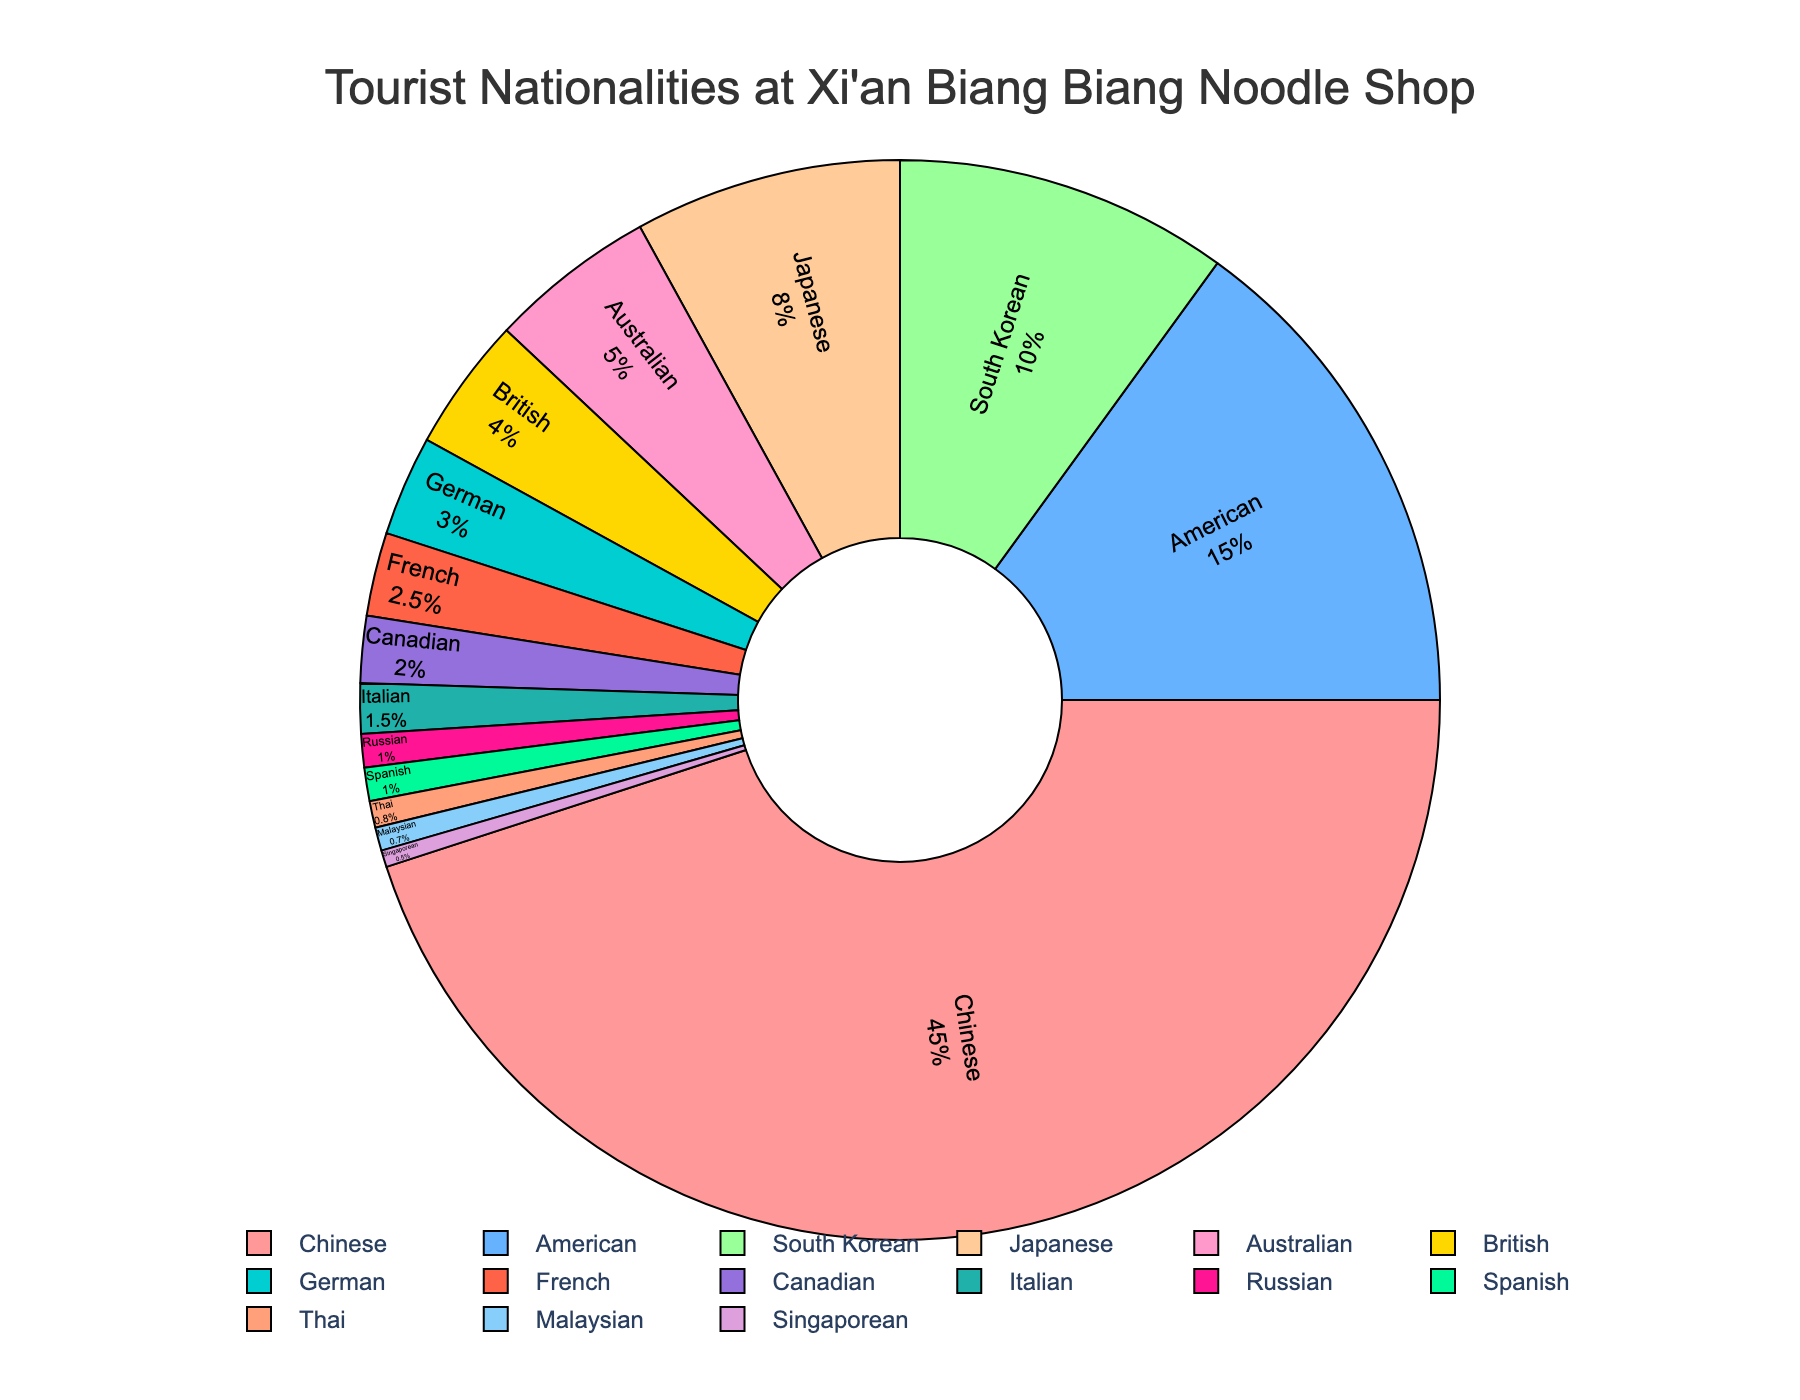What is the percentage of Chinese tourists? The pie chart shows that 45% of the tourists are Chinese.
Answer: 45% Which nationality has the second-highest percentage of tourists? By looking at the pie chart, the second-largest segment is American tourists with 15%.
Answer: American What is the combined percentage of South Korean and Japanese tourists? From the pie chart, South Korean tourists are 10% and Japanese tourists are 8%. Sum them up: 10% + 8% = 18%.
Answer: 18% Is the percentage of British tourists greater than that of German tourists? The pie chart shows that British tourists make up 4%, while German tourists account for 3%. Since 4% is greater than 3%, the statement is true.
Answer: Yes What is the combined percentage of Canadian and Italian tourists? According to the pie chart, Canadian tourists account for 2% and Italian tourists account for 1.5%. Sum them up: 2% + 1.5% = 3.5%.
Answer: 3.5% How much larger is the percentage of Australian tourists compared to the French tourists? The pie chart indicates that Australian tourists make up 5%, while French tourists make up 2.5%. To find the difference: 5% - 2.5% = 2.5%.
Answer: 2.5% Which nationality has the smallest percentage of tourists? The pie chart indicates that the smallest segment is Singaporean tourists with 0.5%.
Answer: Singaporean How much more popular is the shop among American tourists compared to South Korean tourists? American tourists constitute 15% of the total, and South Korean tourists constitute 10%. The difference is: 15% - 10% = 5%.
Answer: 5% What is the percentage of tourists from countries other than China? The pie chart shows that Chinese tourists account for 45% of the total. Therefore, the percentage of tourists from other countries is: 100% - 45% = 55%.
Answer: 55% 